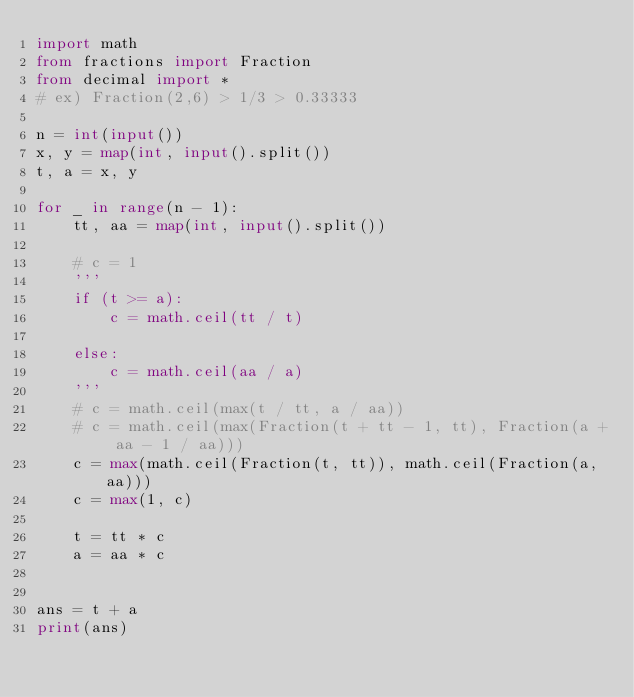<code> <loc_0><loc_0><loc_500><loc_500><_Python_>import math
from fractions import Fraction
from decimal import *
# ex) Fraction(2,6) > 1/3 > 0.33333

n = int(input())
x, y = map(int, input().split())
t, a = x, y

for _ in range(n - 1):
    tt, aa = map(int, input().split())

    # c = 1
    '''
    if (t >= a):
        c = math.ceil(tt / t)

    else:
        c = math.ceil(aa / a)
    '''
    # c = math.ceil(max(t / tt, a / aa))
    # c = math.ceil(max(Fraction(t + tt - 1, tt), Fraction(a + aa - 1 / aa)))
    c = max(math.ceil(Fraction(t, tt)), math.ceil(Fraction(a, aa)))
    c = max(1, c)

    t = tt * c
    a = aa * c


ans = t + a
print(ans)
</code> 